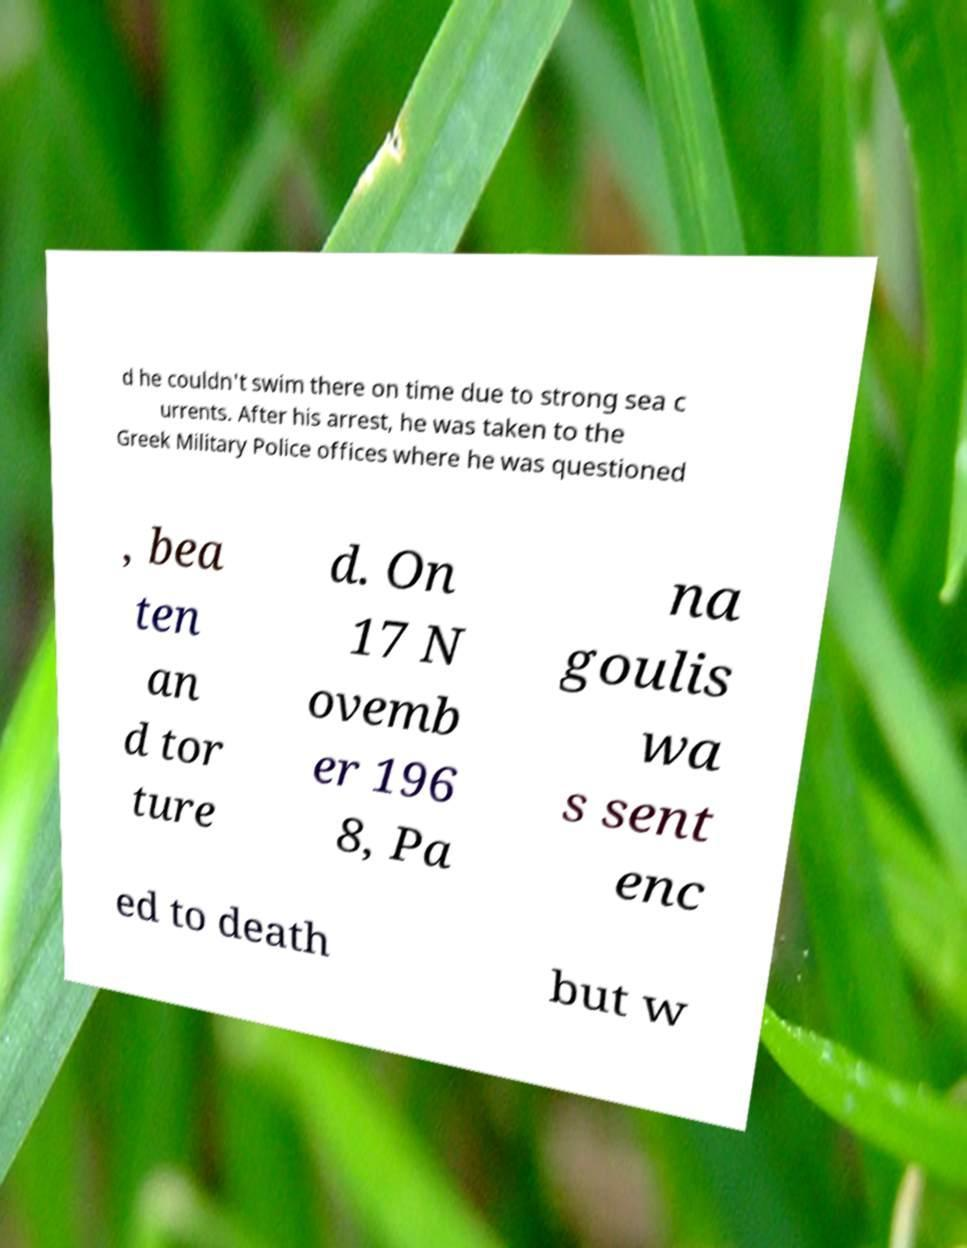There's text embedded in this image that I need extracted. Can you transcribe it verbatim? d he couldn't swim there on time due to strong sea c urrents. After his arrest, he was taken to the Greek Military Police offices where he was questioned , bea ten an d tor ture d. On 17 N ovemb er 196 8, Pa na goulis wa s sent enc ed to death but w 